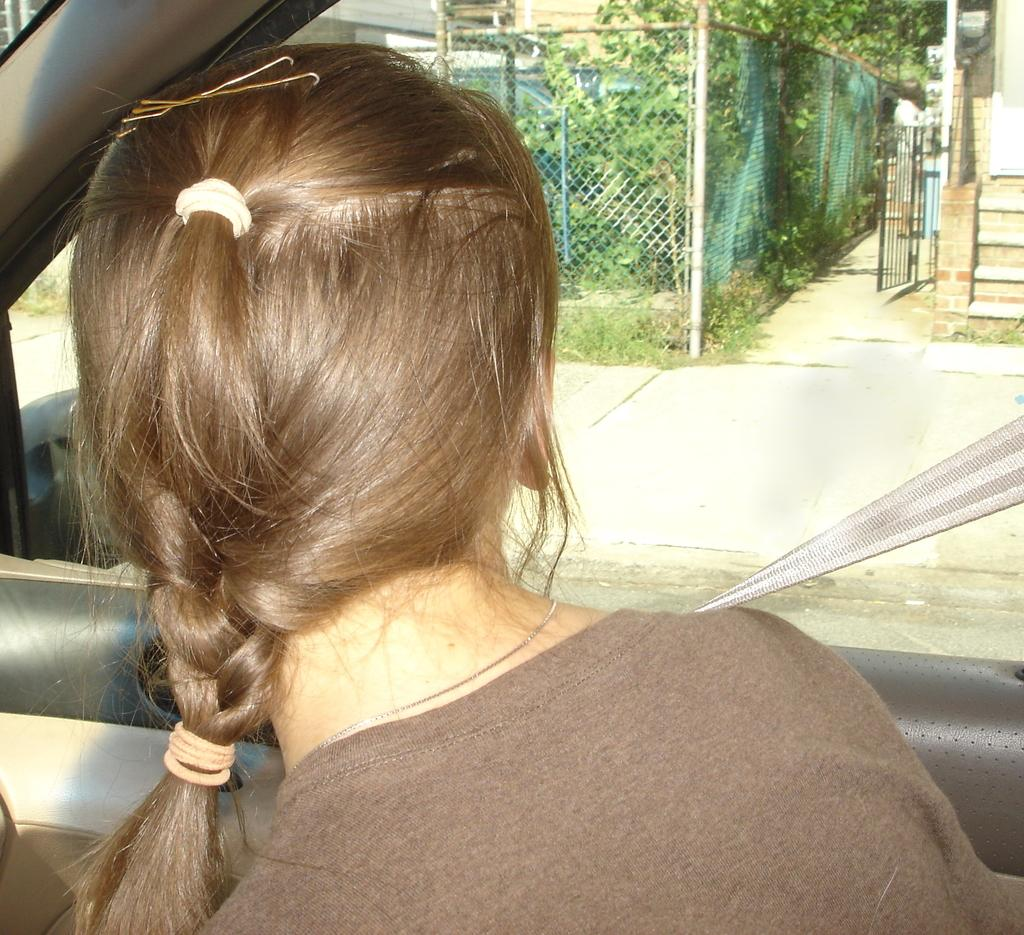What is the girl doing in the car? The girl is sitting in the car and facing outside. What can be seen outside the car? There are gates and trees visible outside the car. What type of brush is the girl using to paint the clouds in the image? There is no brush or clouds present in the image; the girl is sitting in a car facing outside, and there are gates and trees visible outside the car. 